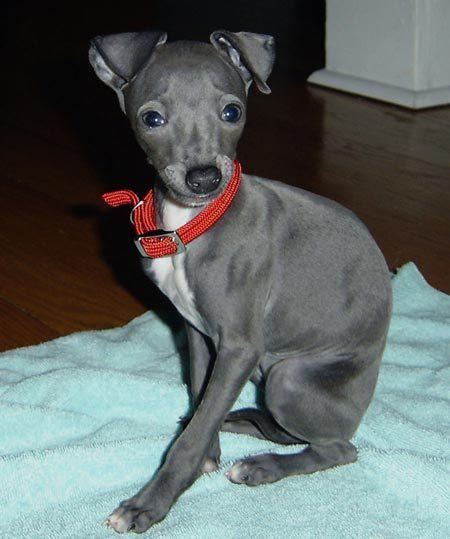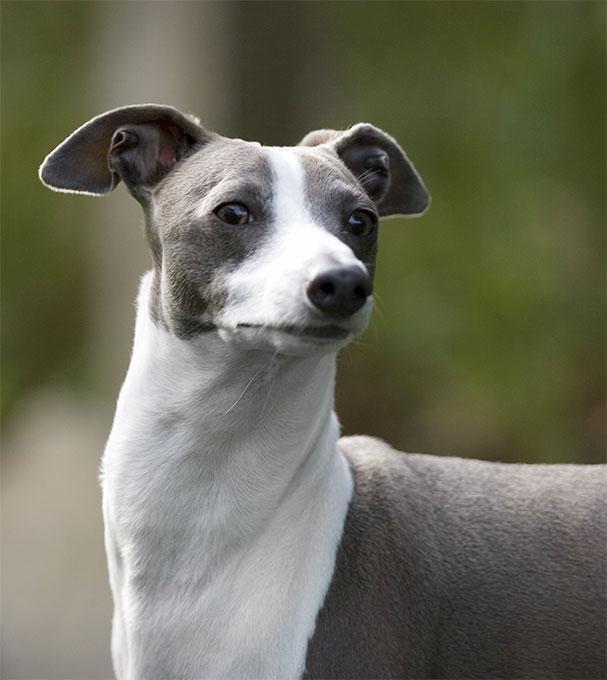The first image is the image on the left, the second image is the image on the right. Analyze the images presented: Is the assertion "There is grass visible in one of the images." valid? Answer yes or no. No. The first image is the image on the left, the second image is the image on the right. For the images shown, is this caption "One dog is in grass." true? Answer yes or no. No. 